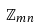Convert formula to latex. <formula><loc_0><loc_0><loc_500><loc_500>\mathbb { Z } _ { m n }</formula> 